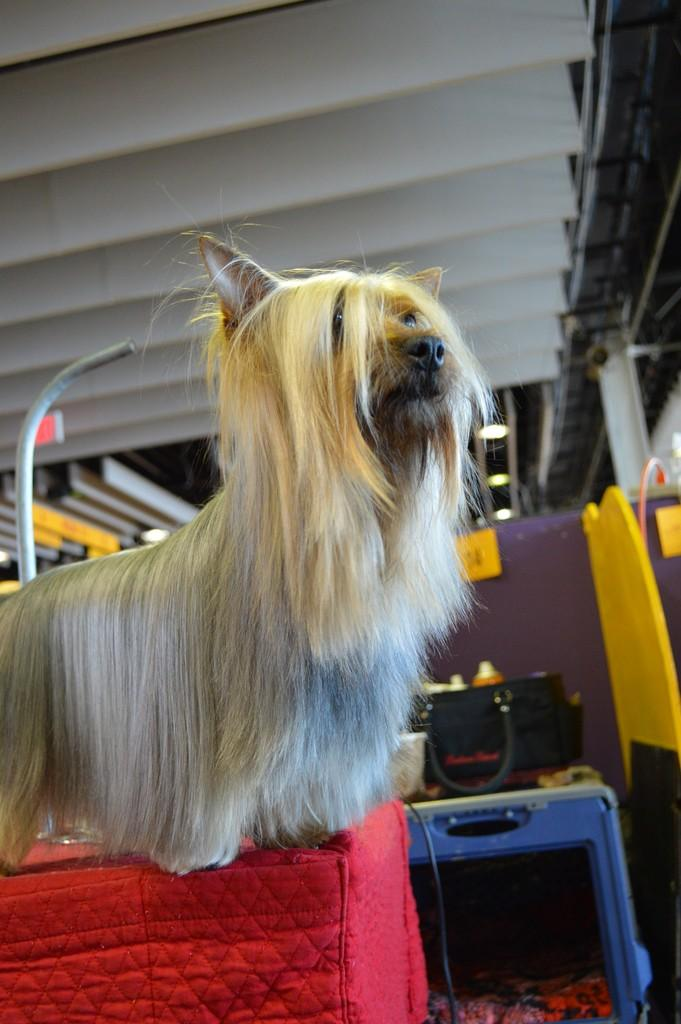What type of animal is in the image? There is a dog in the image. Can you describe the dog's appearance? The dog has a lot of fur. Where is the dog standing in the image? The dog is standing on a red color cloth table. What else can be seen in the image besides the dog? There are objects placed on a path in the image. What type of wrench is the woman using to fix the passenger's car in the image? There is no woman, wrench, or car present in the image; it features a dog standing on a red color cloth table and objects placed on a path. 